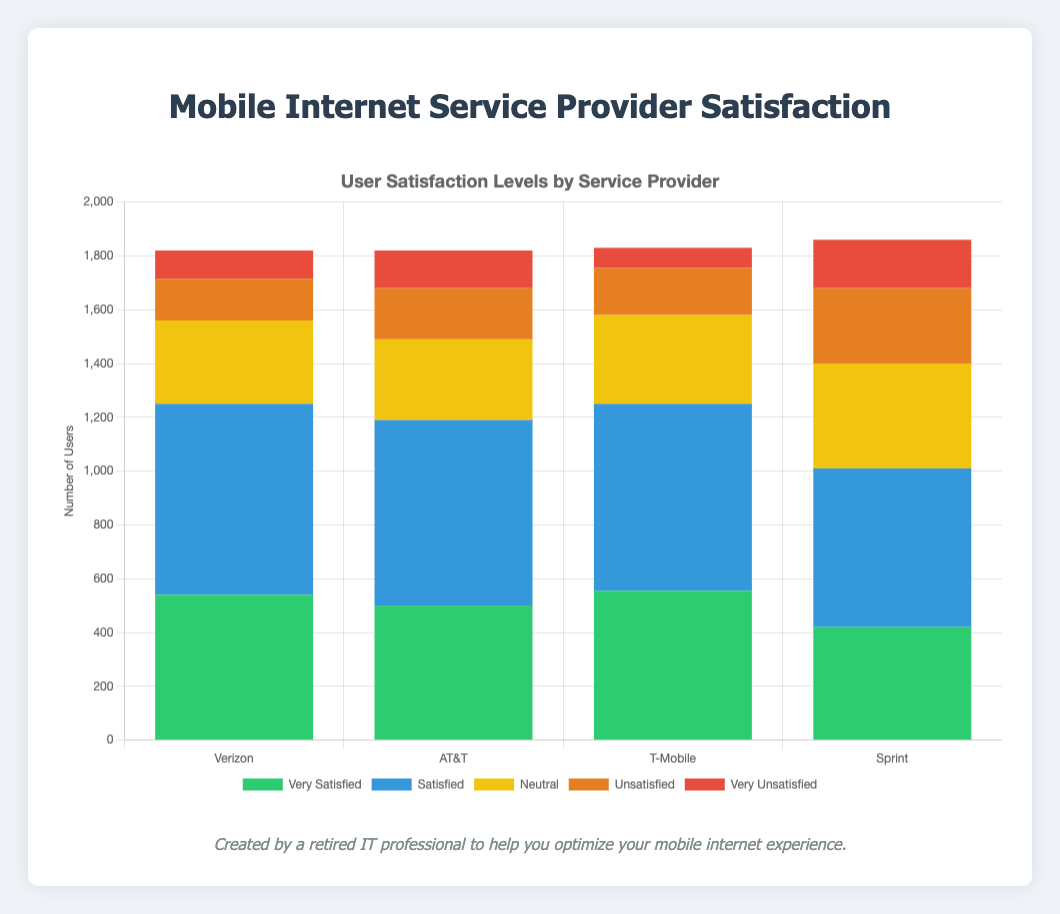Which provider has the highest number of 'Very Unsatisfied' users for the Pricing issue? The stacked bar chart shows the number of users for each satisfaction level by provider and issue. By looking at the Provider column under the Pricing issue, select the 'Very Unsatisfied' category and compare the heights of those corresponding bars. Sprint has the bar with the most height in this category.
Answer: Sprint Total number of 'Satisfied' users for T-Mobile across all issues To find the total, sum the numbers of 'Satisfied' users for each issue under T-Mobile:
- Network Speed: 180
- Connection Stability: 195
- Customer Service: 180
- Pricing: 140
Sum these numbers: 180 + 195 + 180 + 140 = 695
Answer: 695 Which issue has the highest number of 'Neutral' users for Verizon? The stacked bar chart shows the number of users for each satisfaction level by provider and issue. Looking specifically at the Neutral category for Verizon across all issues:
- Network Speed: 50
- Connection Stability: 40
- Customer Service: 100
- Pricing: 120
Pricing has the highest value among these.
Answer: Pricing What's the percentage of 'Unsatisfied' users out of total users for AT&T's Network Speed issue? First, get the total users for AT&T's Network Speed issue by summing all satisfaction levels:
- Very Satisfied: 140
- Satisfied: 190
- Neutral: 70
- Unsatisfied: 40
- Very Unsatisfied: 30
Total = 140 + 190 + 70 + 40 + 30 = 470
Then, calculate the percentage:
(Unsatisfied / Total) * 100 = (40 / 470) * 100 ≈ 8.51%
Answer: 8.51% Compare the number of 'Very Satisfied' users in Network Speed between Verizon and Sprint Check the 'Very Satisfied' category under the Network Speed issue for both providers:
- Verizon: 150
- Sprint: 120
150 (Verizon) > 120 (Sprint)
Answer: Verizon has more Which provider has the greatest proportion of 'Very Satisfied' users in Connection Stability? To determine the proportion, calculate the ratio of 'Very Satisfied' users to the total users for Connection Stability in each provider, then compare:
- Verizon: 180 / (180 + 210 + 40 + 15 + 25) = 180 / 470 ≈ 0.383
- AT&T: 170 / (170 + 220 + 30 + 20 + 10) = 170 / 450 ≈ 0.378
- T-Mobile: 175 / (175 + 195 + 50 + 25 + 5) = 175 / 450 ≈ 0.389
- Sprint: 140 / (140 + 190 + 50 + 40 + 20) = 140 / 440 ≈ 0.318
T-Mobile has the highest proportion.
Answer: T-Mobile Identify the issue with the most total users across all providers Sum the total number of users for each issue across all providers, and then compare:
- Network Speed: (150 + 200 + 50 + 30 + 20) + (140 + 190 + 70 + 40 + 30) + (160 + 180 + 60 + 20 + 10) + (120 + 160 + 80 + 70 + 50) = 1330
- Connection Stability: (180 + 210 + 40 + 15 + 25) + (170 + 220 + 30 + 20 + 10) + (175 + 195 + 50 + 25 + 5) + (140 + 190 + 50 + 40 + 20) = 1550
- Customer Service: (130 + 160 + 100 + 60 + 20) + (100 + 150 + 90 + 70 + 40) + (120 + 180 + 90 + 50 + 30) + (90 + 130 + 120 + 80 + 50) = 1970
- Pricing: (80 + 140 + 120 + 50 + 40) + (90 + 130 + 110 + 60 + 60) + (100 + 140 + 130 + 80 + 30) + (70 + 110 + 140 + 90 + 60) = 1640
Customer Service has the highest total.
Answer: Customer Service 